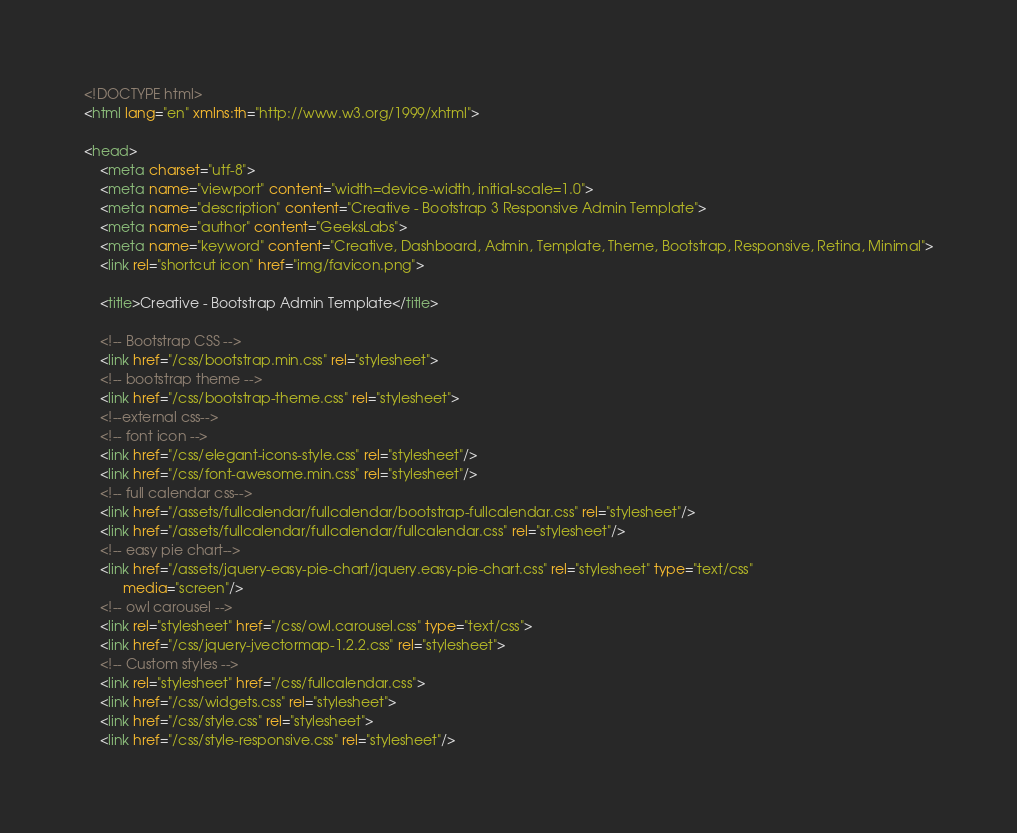<code> <loc_0><loc_0><loc_500><loc_500><_HTML_><!DOCTYPE html>
<html lang="en" xmlns:th="http://www.w3.org/1999/xhtml">

<head>
    <meta charset="utf-8">
    <meta name="viewport" content="width=device-width, initial-scale=1.0">
    <meta name="description" content="Creative - Bootstrap 3 Responsive Admin Template">
    <meta name="author" content="GeeksLabs">
    <meta name="keyword" content="Creative, Dashboard, Admin, Template, Theme, Bootstrap, Responsive, Retina, Minimal">
    <link rel="shortcut icon" href="img/favicon.png">

    <title>Creative - Bootstrap Admin Template</title>

    <!-- Bootstrap CSS -->
    <link href="/css/bootstrap.min.css" rel="stylesheet">
    <!-- bootstrap theme -->
    <link href="/css/bootstrap-theme.css" rel="stylesheet">
    <!--external css-->
    <!-- font icon -->
    <link href="/css/elegant-icons-style.css" rel="stylesheet"/>
    <link href="/css/font-awesome.min.css" rel="stylesheet"/>
    <!-- full calendar css-->
    <link href="/assets/fullcalendar/fullcalendar/bootstrap-fullcalendar.css" rel="stylesheet"/>
    <link href="/assets/fullcalendar/fullcalendar/fullcalendar.css" rel="stylesheet"/>
    <!-- easy pie chart-->
    <link href="/assets/jquery-easy-pie-chart/jquery.easy-pie-chart.css" rel="stylesheet" type="text/css"
          media="screen"/>
    <!-- owl carousel -->
    <link rel="stylesheet" href="/css/owl.carousel.css" type="text/css">
    <link href="/css/jquery-jvectormap-1.2.2.css" rel="stylesheet">
    <!-- Custom styles -->
    <link rel="stylesheet" href="/css/fullcalendar.css">
    <link href="/css/widgets.css" rel="stylesheet">
    <link href="/css/style.css" rel="stylesheet">
    <link href="/css/style-responsive.css" rel="stylesheet"/></code> 